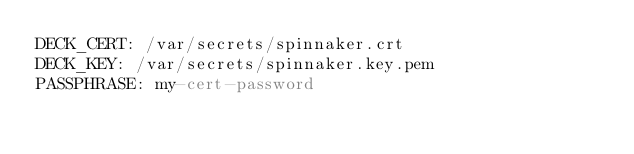<code> <loc_0><loc_0><loc_500><loc_500><_YAML_>DECK_CERT: /var/secrets/spinnaker.crt
DECK_KEY: /var/secrets/spinnaker.key.pem
PASSPHRASE: my-cert-password
</code> 